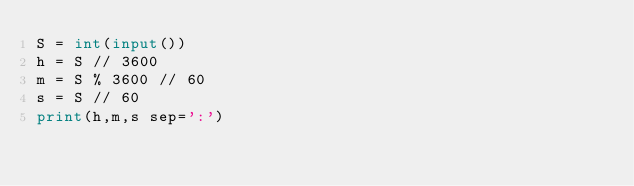<code> <loc_0><loc_0><loc_500><loc_500><_Python_>S = int(input())
h = S // 3600
m = S % 3600 // 60
s = S // 60
print(h,m,s sep=':')</code> 